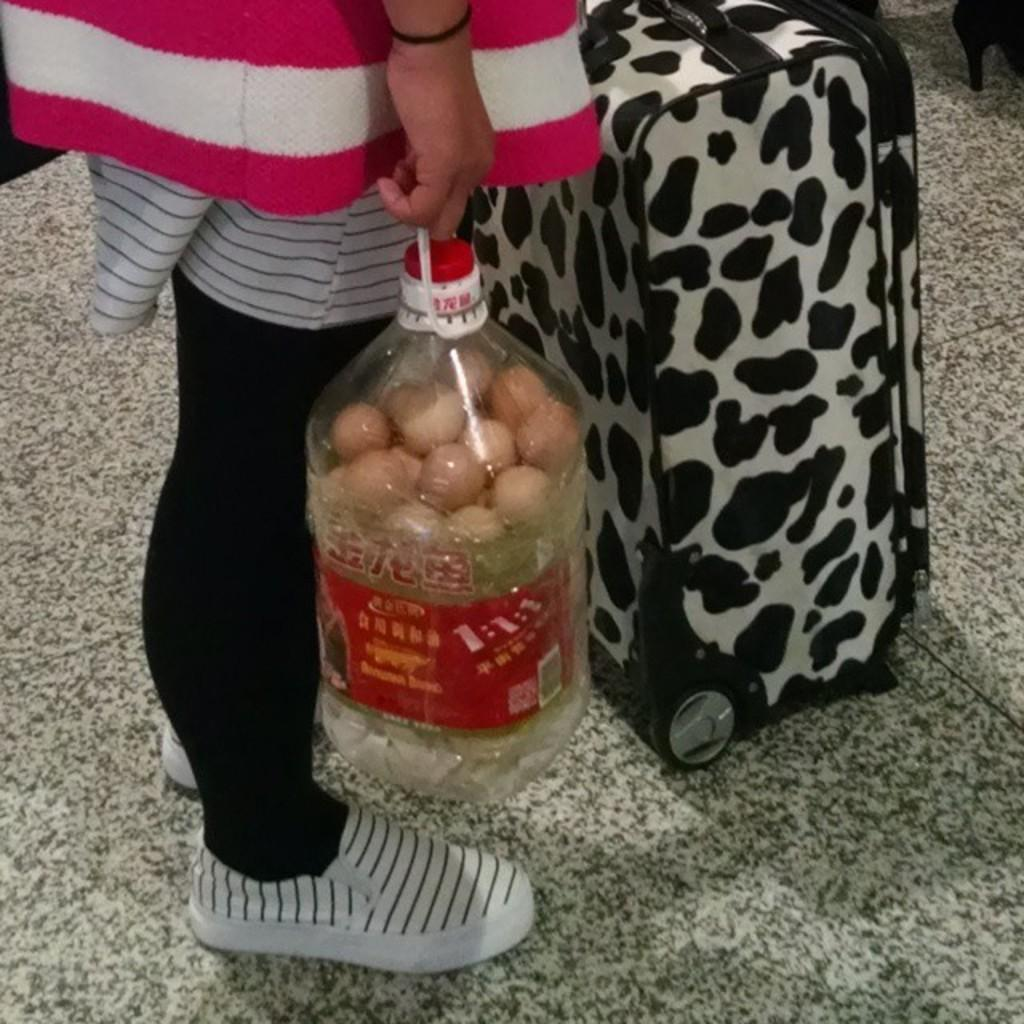Who is present in the image? There is a woman in the image. What is the woman doing in the image? The woman is standing in the image. What object is the woman holding? The woman is holding a bottle in the image. What can be seen in the front of the image? There is a suitcase in the front of the image. What type of potato is the woman holding in the image? There is no potato present in the image; the woman is holding a bottle. Can you hear the woman whistling in the image? There is no indication of whistling in the image, as the focus is on the woman holding a bottle and standing near a suitcase. 